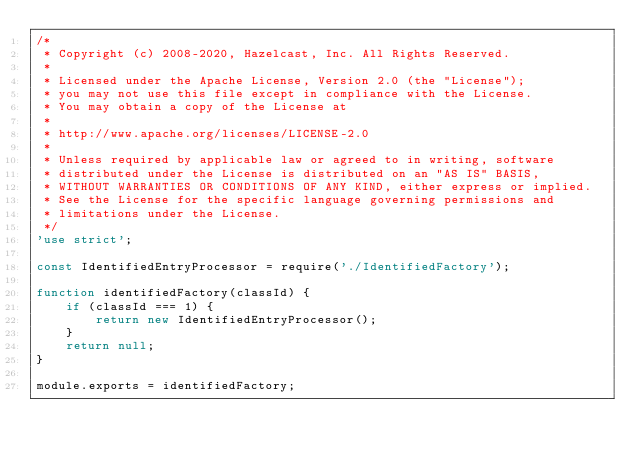<code> <loc_0><loc_0><loc_500><loc_500><_JavaScript_>/*
 * Copyright (c) 2008-2020, Hazelcast, Inc. All Rights Reserved.
 *
 * Licensed under the Apache License, Version 2.0 (the "License");
 * you may not use this file except in compliance with the License.
 * You may obtain a copy of the License at
 *
 * http://www.apache.org/licenses/LICENSE-2.0
 *
 * Unless required by applicable law or agreed to in writing, software
 * distributed under the License is distributed on an "AS IS" BASIS,
 * WITHOUT WARRANTIES OR CONDITIONS OF ANY KIND, either express or implied.
 * See the License for the specific language governing permissions and
 * limitations under the License.
 */
'use strict';

const IdentifiedEntryProcessor = require('./IdentifiedFactory');

function identifiedFactory(classId) {
    if (classId === 1) {
        return new IdentifiedEntryProcessor();
    }
    return null;
}

module.exports = identifiedFactory;
</code> 